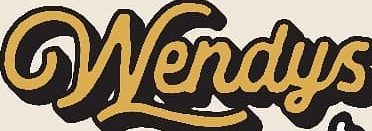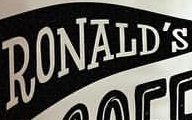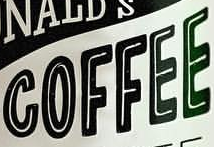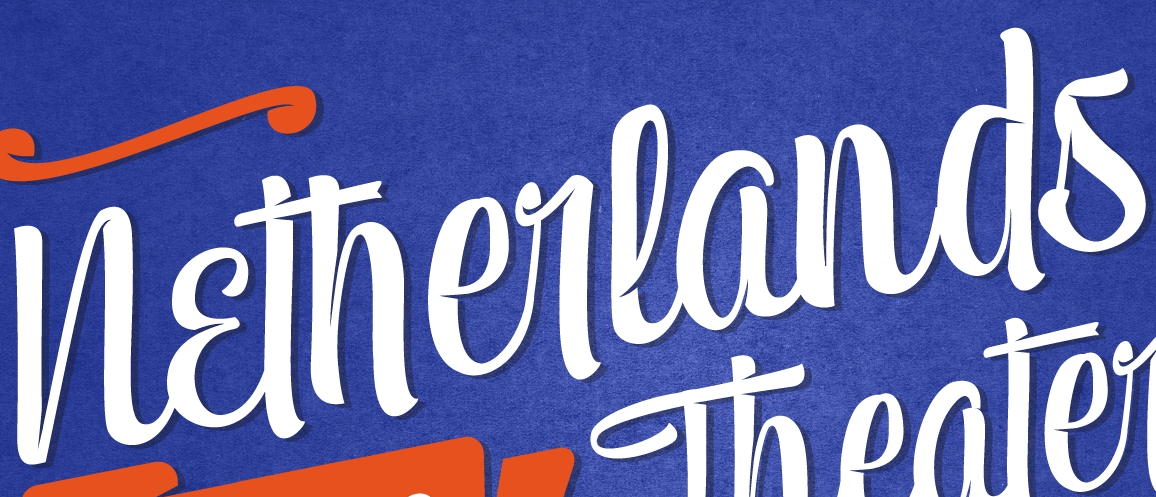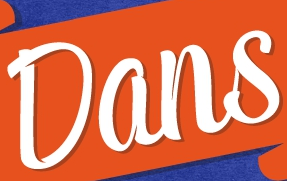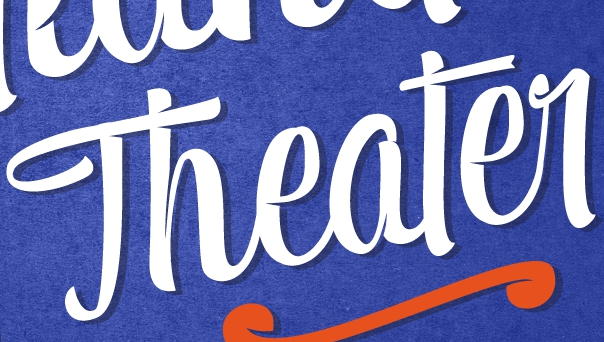What words can you see in these images in sequence, separated by a semicolon? Wendys; RONALD'S; COFFEE; Netherlands; Dans; Theater 